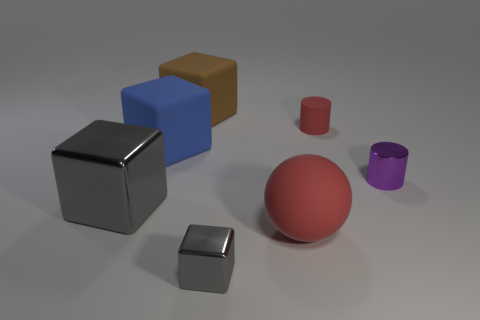Subtract 1 cubes. How many cubes are left? 3 Add 2 large blue metallic objects. How many objects exist? 9 Subtract all balls. How many objects are left? 6 Subtract all tiny metallic cubes. Subtract all blue objects. How many objects are left? 5 Add 7 gray objects. How many gray objects are left? 9 Add 3 small yellow rubber cylinders. How many small yellow rubber cylinders exist? 3 Subtract 1 brown cubes. How many objects are left? 6 